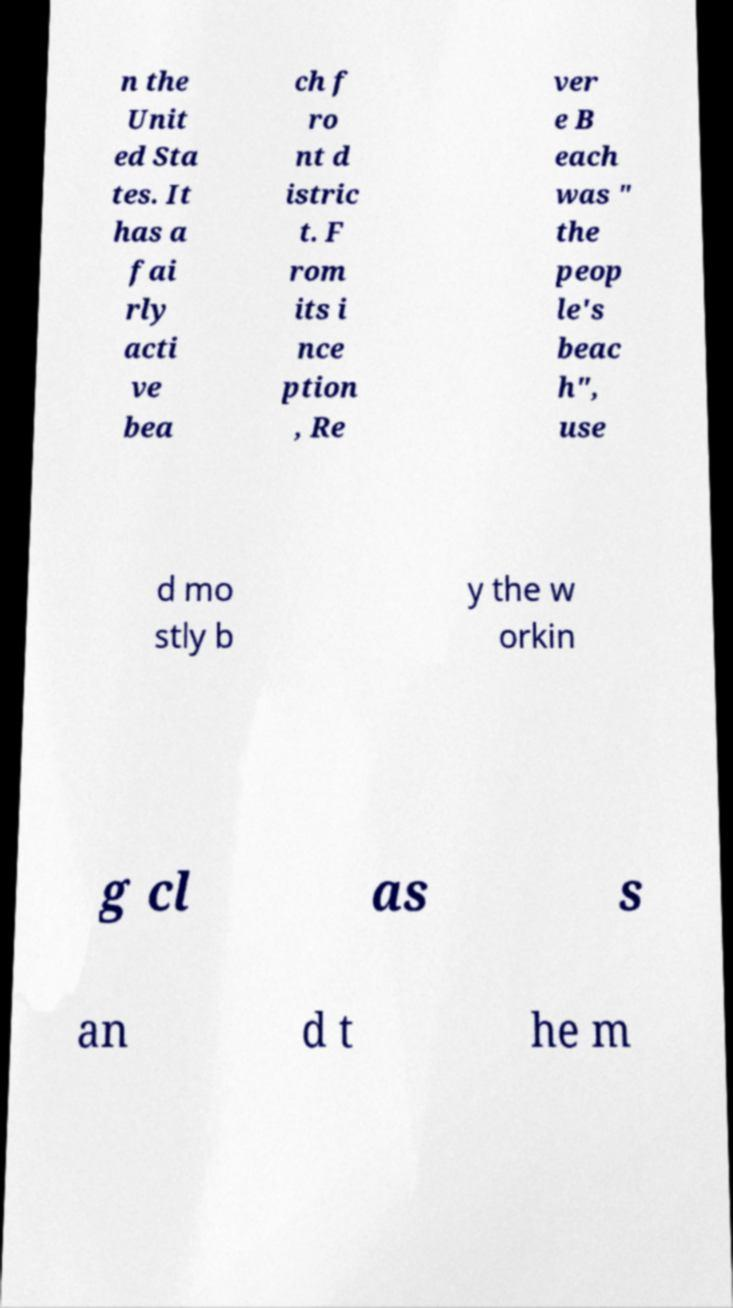For documentation purposes, I need the text within this image transcribed. Could you provide that? n the Unit ed Sta tes. It has a fai rly acti ve bea ch f ro nt d istric t. F rom its i nce ption , Re ver e B each was " the peop le's beac h", use d mo stly b y the w orkin g cl as s an d t he m 